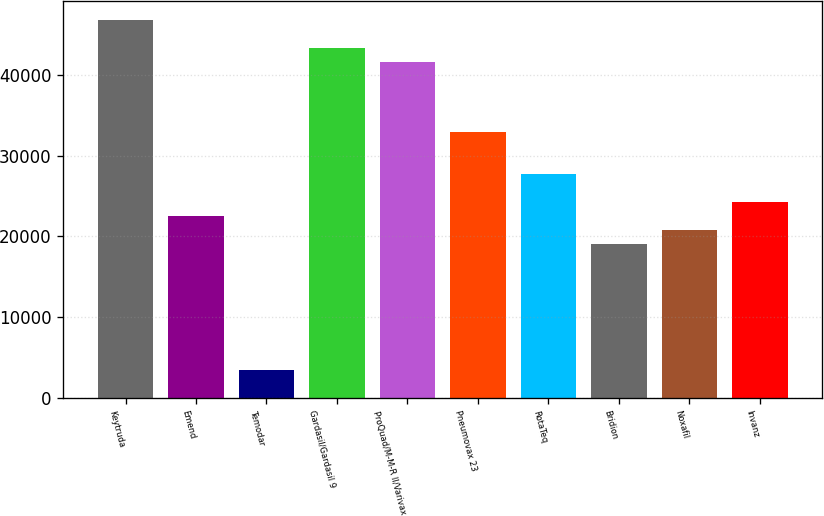Convert chart. <chart><loc_0><loc_0><loc_500><loc_500><bar_chart><fcel>Keytruda<fcel>Emend<fcel>Temodar<fcel>Gardasil/Gardasil 9<fcel>ProQuad/M-M-R II/Varivax<fcel>Pneumovax 23<fcel>RotaTeq<fcel>Bridion<fcel>Noxafil<fcel>Invanz<nl><fcel>46807.8<fcel>22540.2<fcel>3472.8<fcel>43341<fcel>41607.6<fcel>32940.6<fcel>27740.4<fcel>19073.4<fcel>20806.8<fcel>24273.6<nl></chart> 